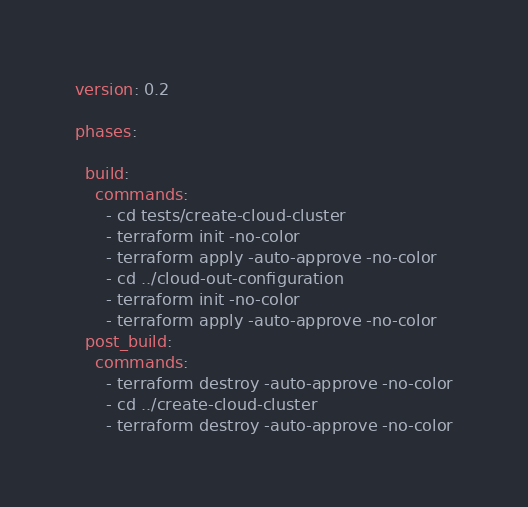<code> <loc_0><loc_0><loc_500><loc_500><_YAML_>version: 0.2

phases:
 
  build:
    commands:
      - cd tests/create-cloud-cluster
      - terraform init -no-color
      - terraform apply -auto-approve -no-color
      - cd ../cloud-out-configuration
      - terraform init -no-color
      - terraform apply -auto-approve -no-color
  post_build:
    commands:
      - terraform destroy -auto-approve -no-color
      - cd ../create-cloud-cluster
      - terraform destroy -auto-approve -no-color</code> 